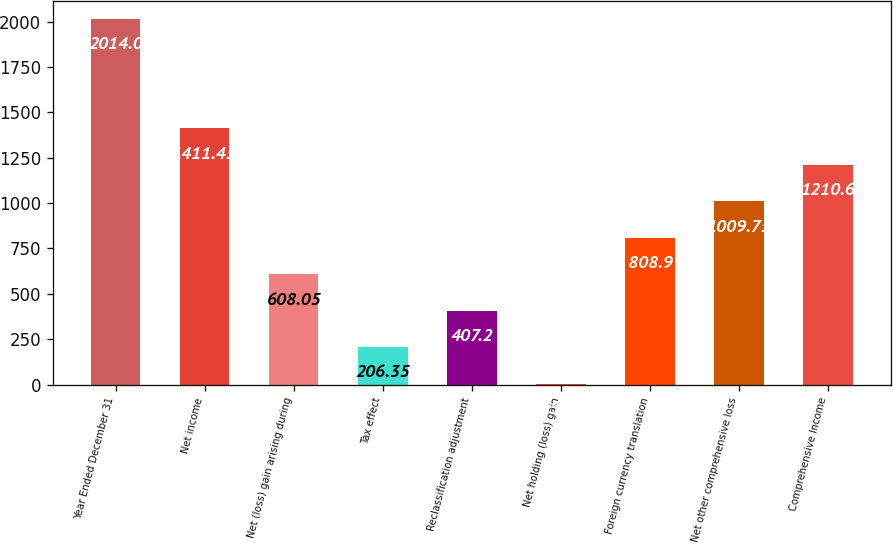<chart> <loc_0><loc_0><loc_500><loc_500><bar_chart><fcel>Year Ended December 31<fcel>Net income<fcel>Net (loss) gain arising during<fcel>Tax effect<fcel>Reclassification adjustment<fcel>Net holding (loss) gain<fcel>Foreign currency translation<fcel>Net other comprehensive loss<fcel>Comprehensive Income<nl><fcel>2014<fcel>1411.45<fcel>608.05<fcel>206.35<fcel>407.2<fcel>5.5<fcel>808.9<fcel>1009.75<fcel>1210.6<nl></chart> 